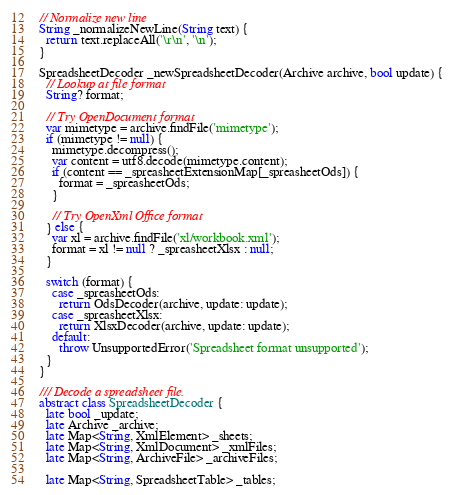Convert code to text. <code><loc_0><loc_0><loc_500><loc_500><_Dart_>
// Normalize new line
String _normalizeNewLine(String text) {
  return text.replaceAll('\r\n', '\n');
}

SpreadsheetDecoder _newSpreadsheetDecoder(Archive archive, bool update) {
  // Lookup at file format
  String? format;

  // Try OpenDocument format
  var mimetype = archive.findFile('mimetype');
  if (mimetype != null) {
    mimetype.decompress();
    var content = utf8.decode(mimetype.content);
    if (content == _spreasheetExtensionMap[_spreasheetOds]) {
      format = _spreasheetOds;
    }

    // Try OpenXml Office format
  } else {
    var xl = archive.findFile('xl/workbook.xml');
    format = xl != null ? _spreasheetXlsx : null;
  }

  switch (format) {
    case _spreasheetOds:
      return OdsDecoder(archive, update: update);
    case _spreasheetXlsx:
      return XlsxDecoder(archive, update: update);
    default:
      throw UnsupportedError('Spreadsheet format unsupported');
  }
}

/// Decode a spreadsheet file.
abstract class SpreadsheetDecoder {
  late bool _update;
  late Archive _archive;
  late Map<String, XmlElement> _sheets;
  late Map<String, XmlDocument> _xmlFiles;
  late Map<String, ArchiveFile> _archiveFiles;

  late Map<String, SpreadsheetTable> _tables;
</code> 